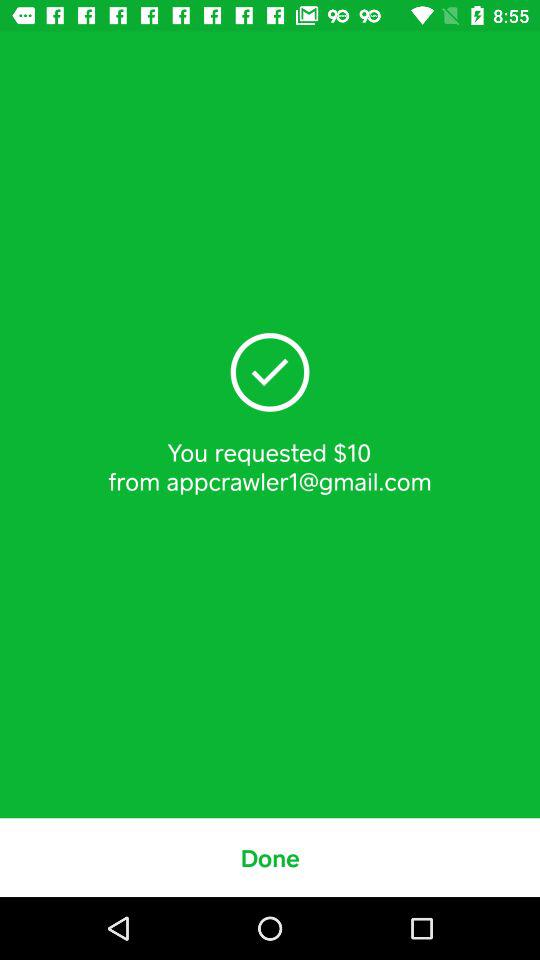How much money is the user requesting?
Answer the question using a single word or phrase. $10 